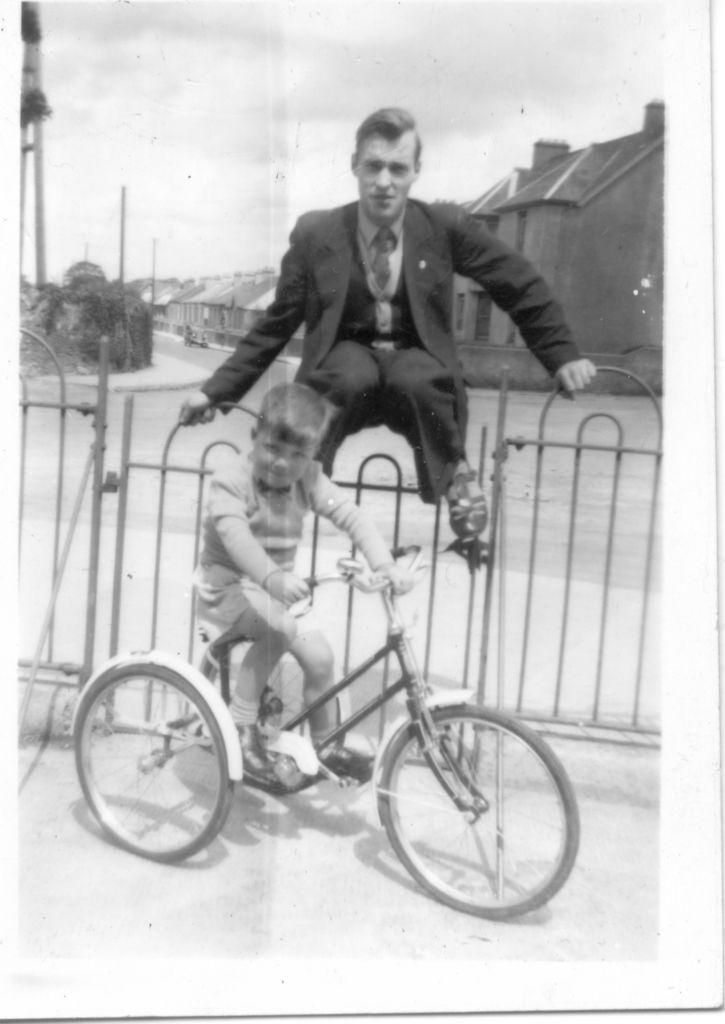What is the kid doing in the image? The kid is riding a vehicle on the road. What is happening to the person in the image? A person is on the grill of the vehicle. What can be seen in the background of the image? There are houses, trees, poles, and the sky visible in the background of the image. Where is the nearest hospital to the location of the vehicle in the image? The image does not provide information about the location of the vehicle or the nearest hospital. 